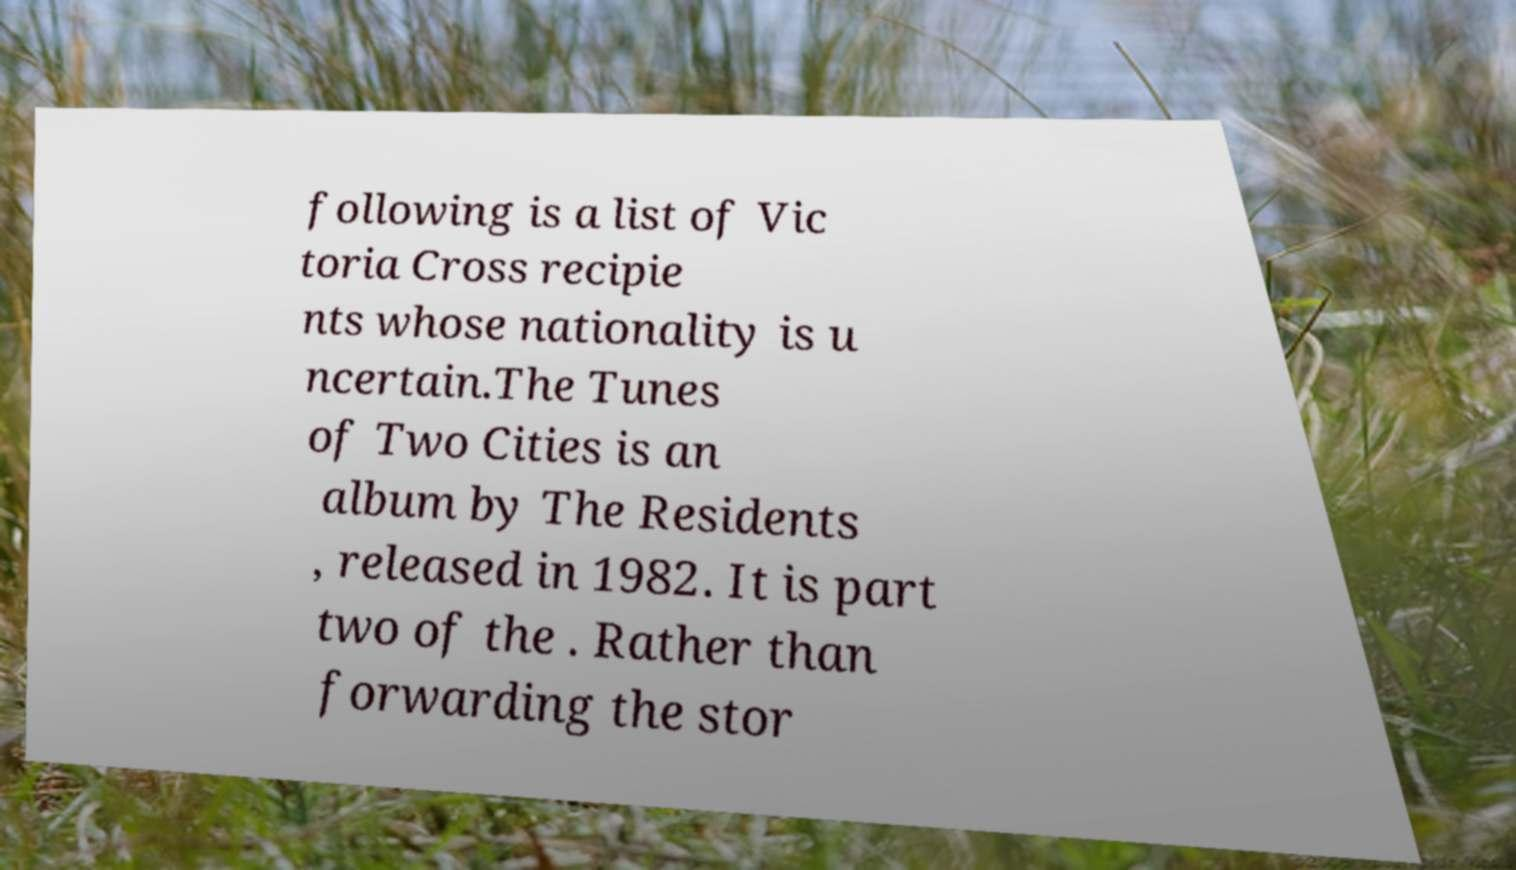Can you accurately transcribe the text from the provided image for me? following is a list of Vic toria Cross recipie nts whose nationality is u ncertain.The Tunes of Two Cities is an album by The Residents , released in 1982. It is part two of the . Rather than forwarding the stor 